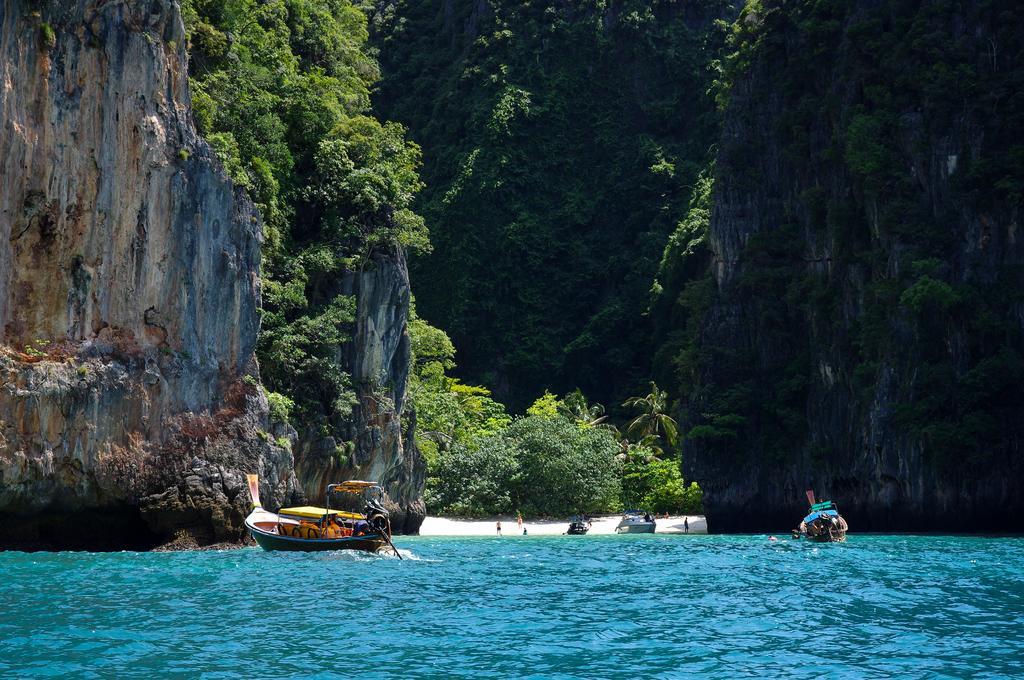Could you give a brief overview of what you see in this image? In this picture we can see water and couple of boats in the water, in the background we can find hills, couple of peoples and trees. 